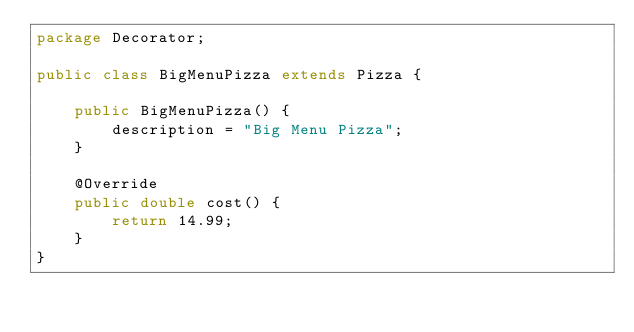<code> <loc_0><loc_0><loc_500><loc_500><_Java_>package Decorator;

public class BigMenuPizza extends Pizza {

    public BigMenuPizza() {
        description = "Big Menu Pizza";
    }

    @Override
    public double cost() {
        return 14.99;
    }
}
</code> 